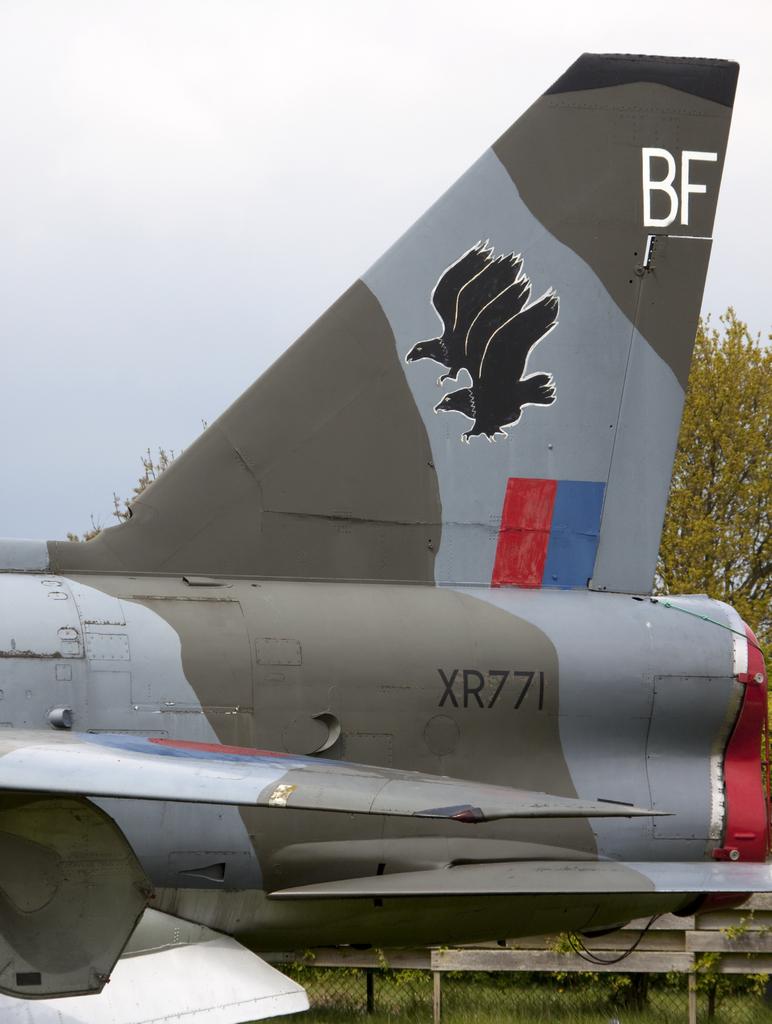What is the plane number?
Offer a terse response. Xr771. What model of plane is this?
Ensure brevity in your answer.  Xr771. 